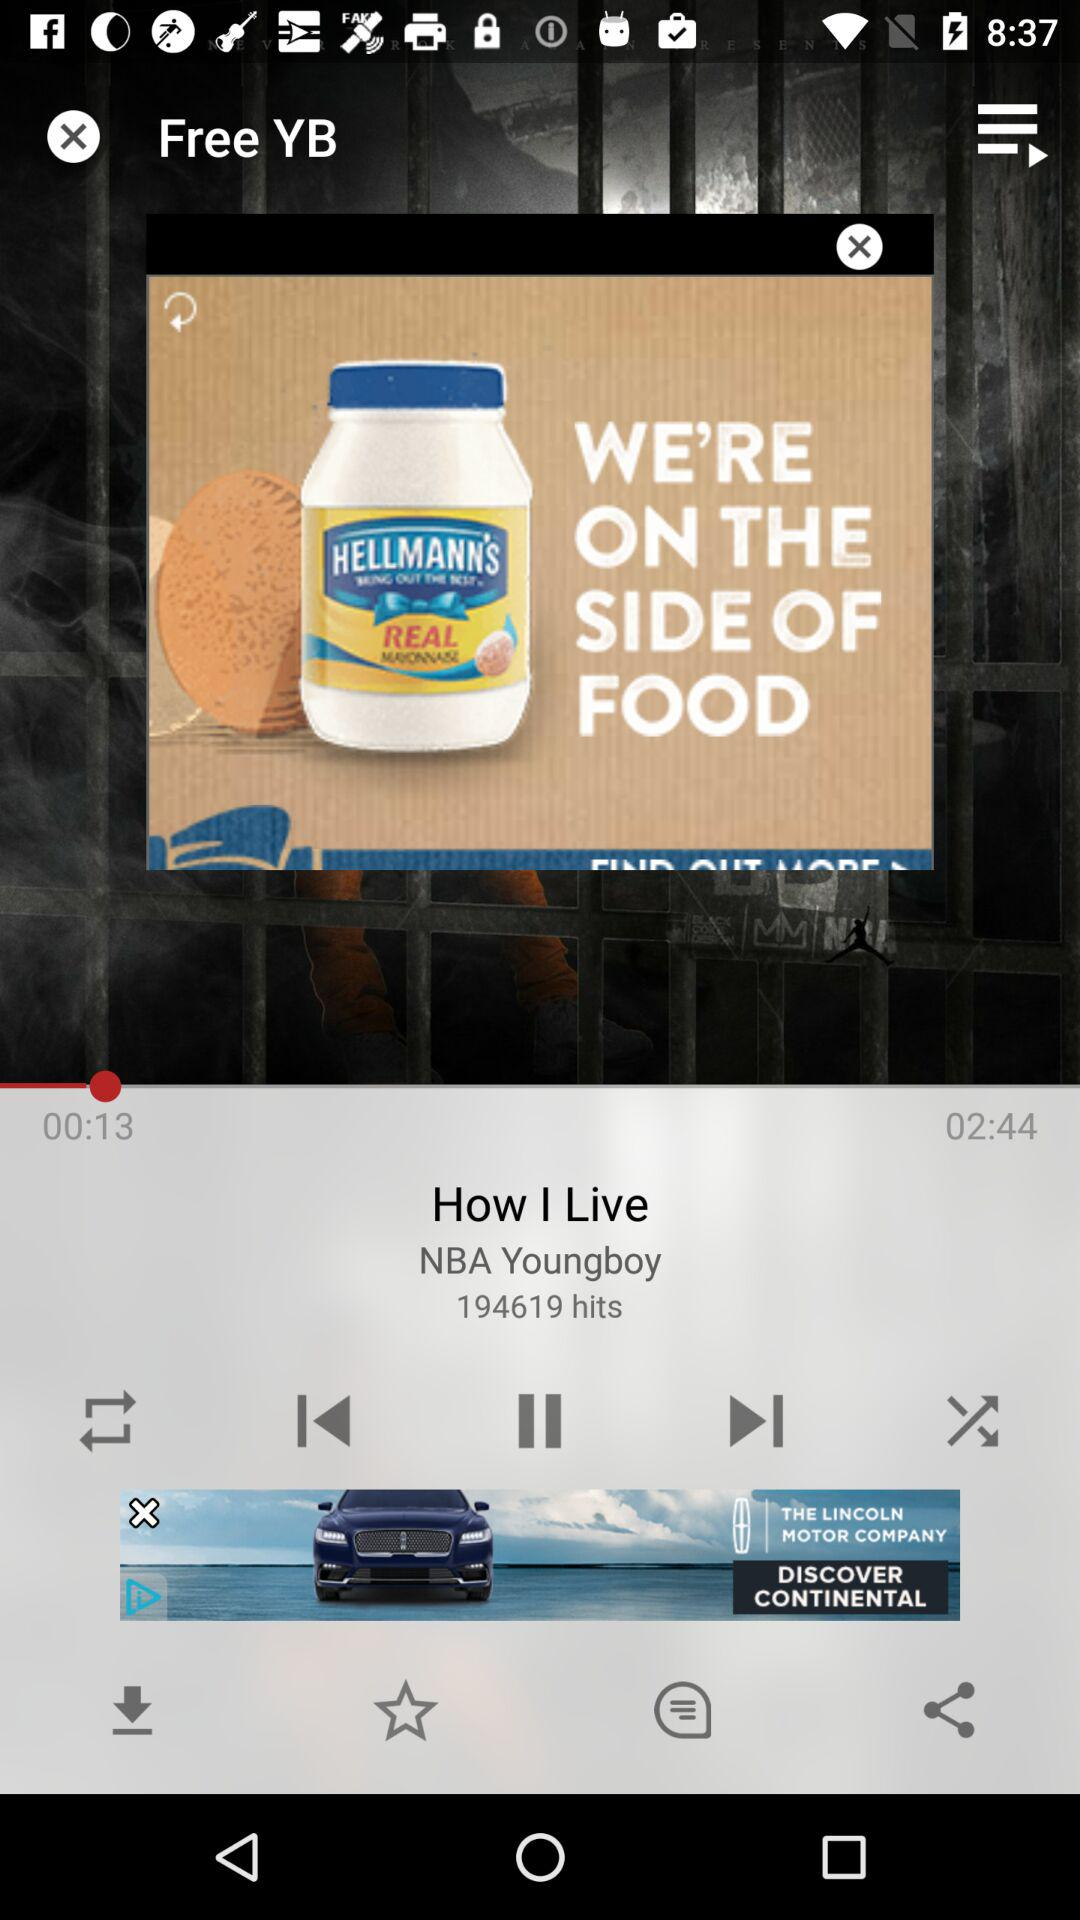What is the name of the currently playing song? The currently playing song is "How I Live". 